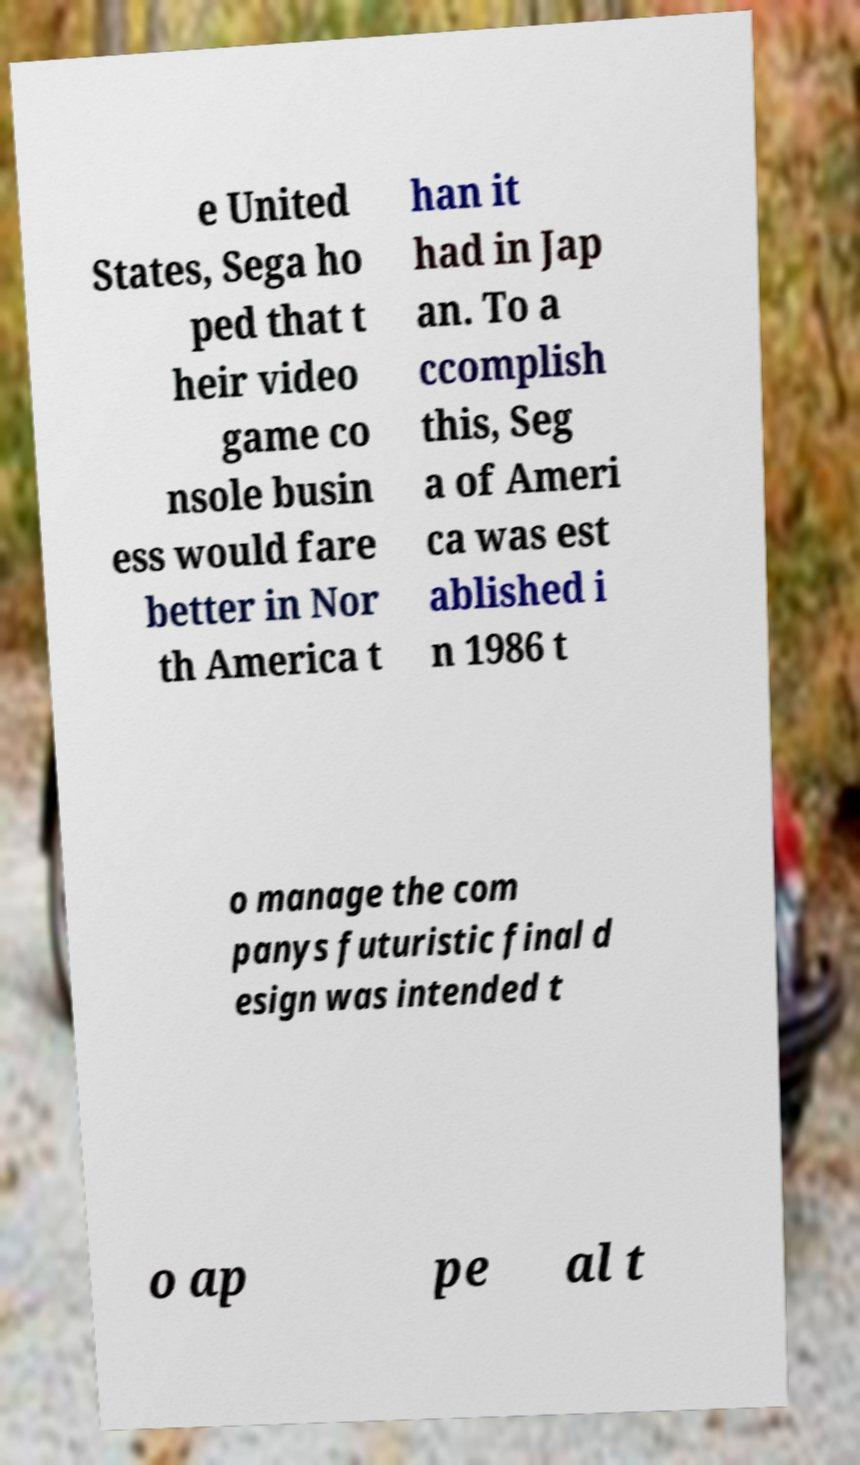Please identify and transcribe the text found in this image. e United States, Sega ho ped that t heir video game co nsole busin ess would fare better in Nor th America t han it had in Jap an. To a ccomplish this, Seg a of Ameri ca was est ablished i n 1986 t o manage the com panys futuristic final d esign was intended t o ap pe al t 